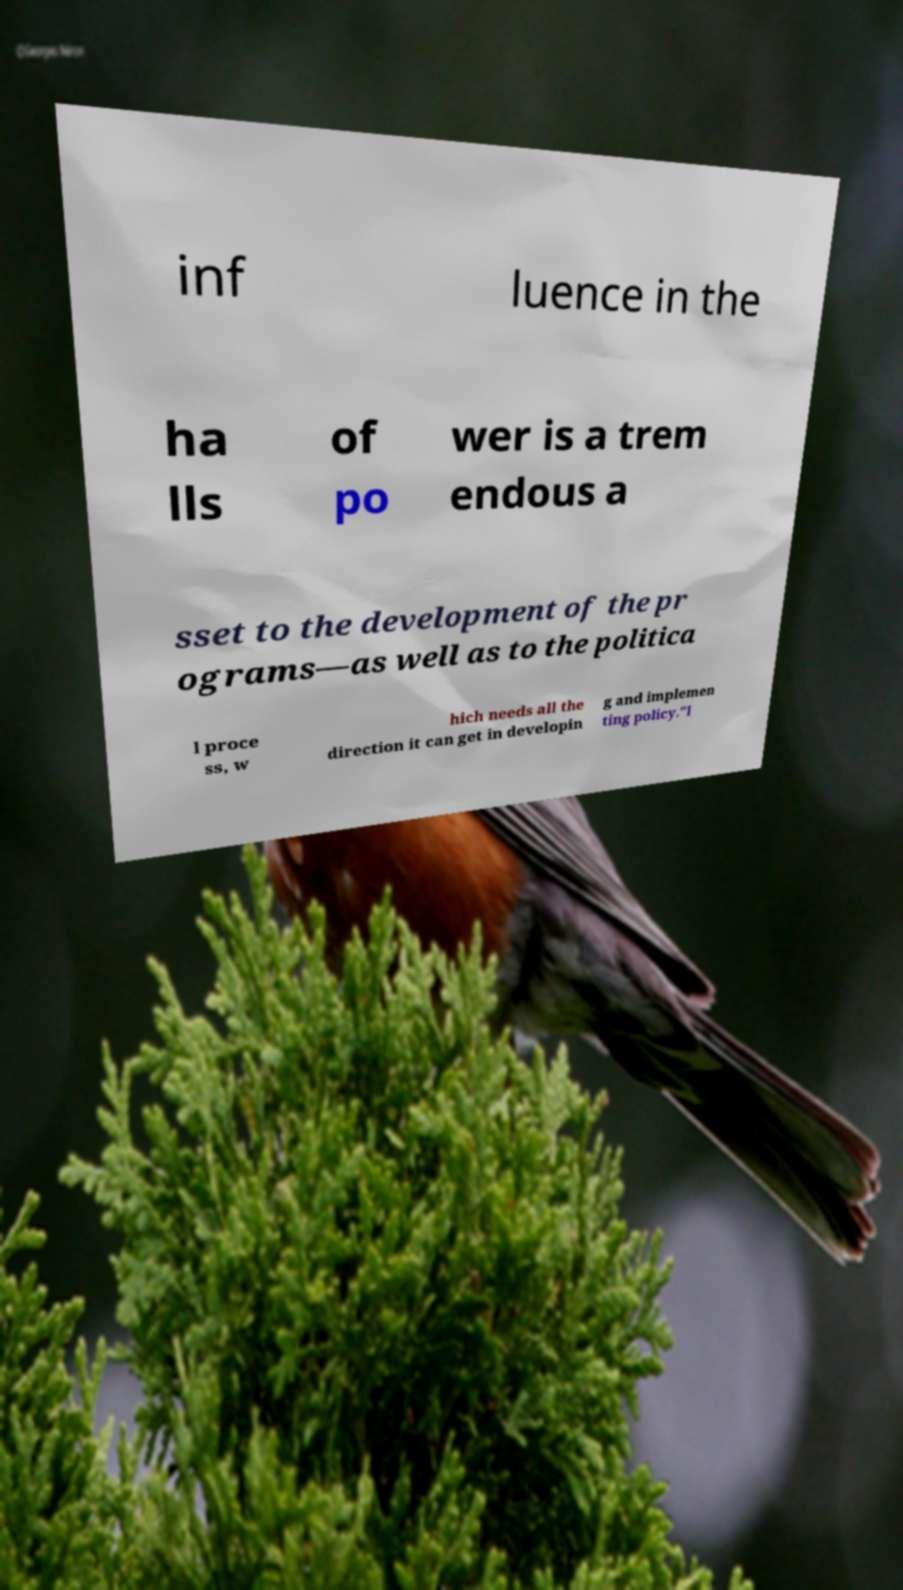Could you extract and type out the text from this image? inf luence in the ha lls of po wer is a trem endous a sset to the development of the pr ograms—as well as to the politica l proce ss, w hich needs all the direction it can get in developin g and implemen ting policy."I 